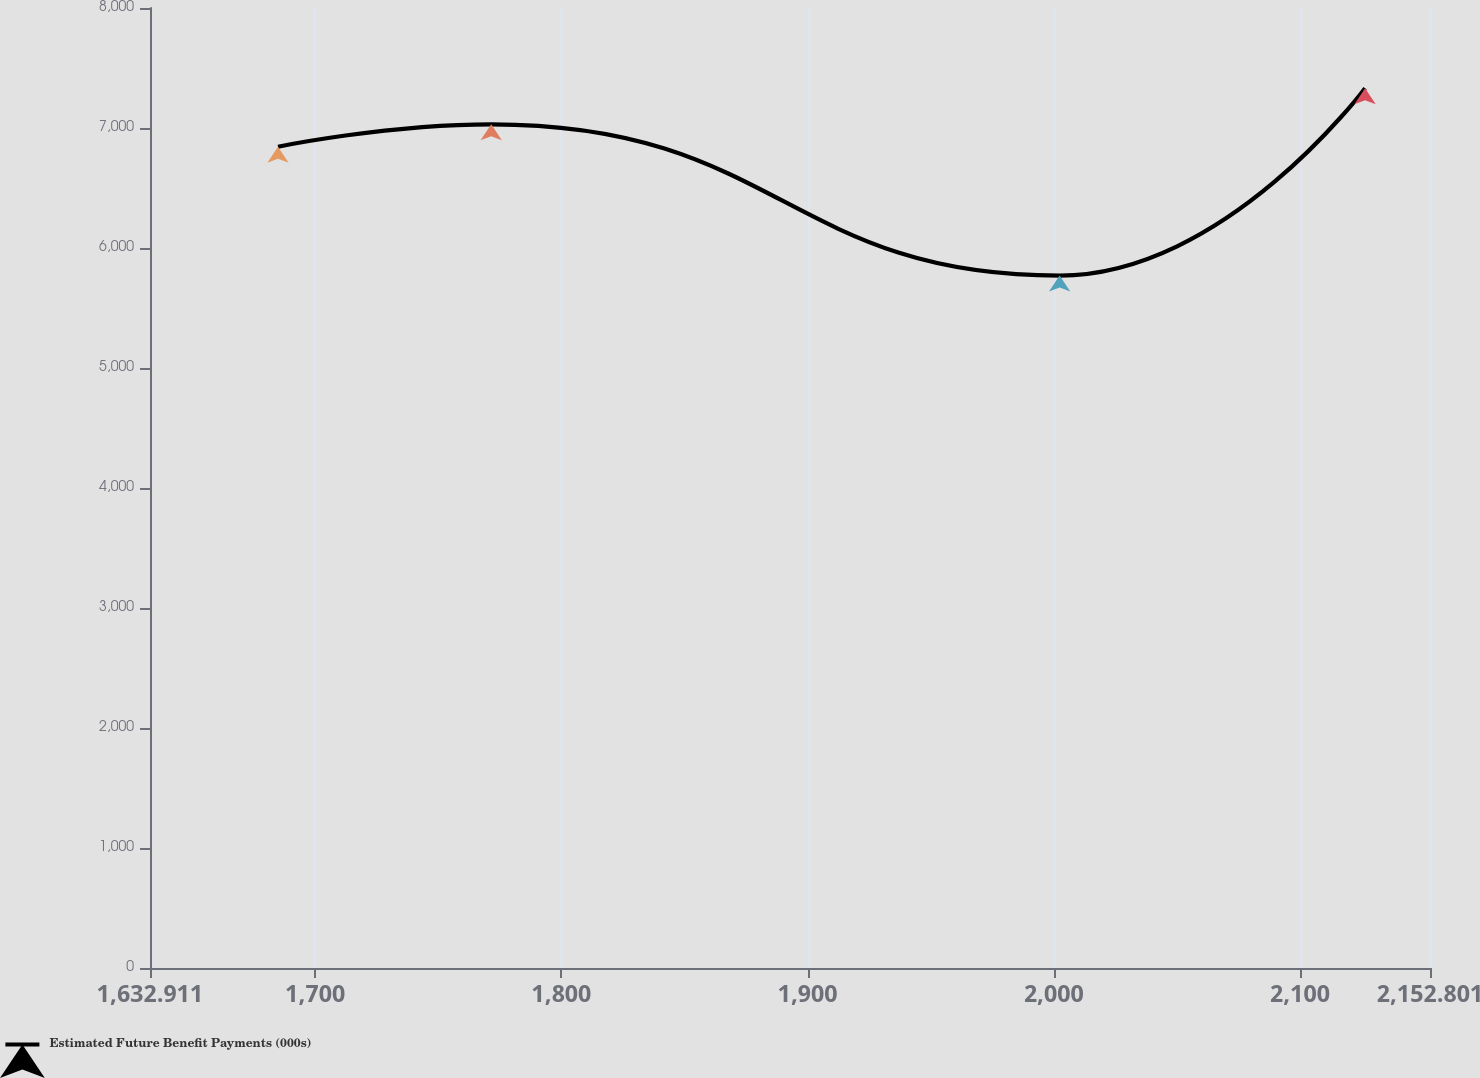Convert chart to OTSL. <chart><loc_0><loc_0><loc_500><loc_500><line_chart><ecel><fcel>Estimated Future Benefit Payments (000s)<nl><fcel>1684.9<fcel>6843.9<nl><fcel>1771.49<fcel>7030.97<nl><fcel>2002.38<fcel>5769.98<nl><fcel>2126.44<fcel>7332.13<nl><fcel>2204.79<fcel>7181.55<nl></chart> 